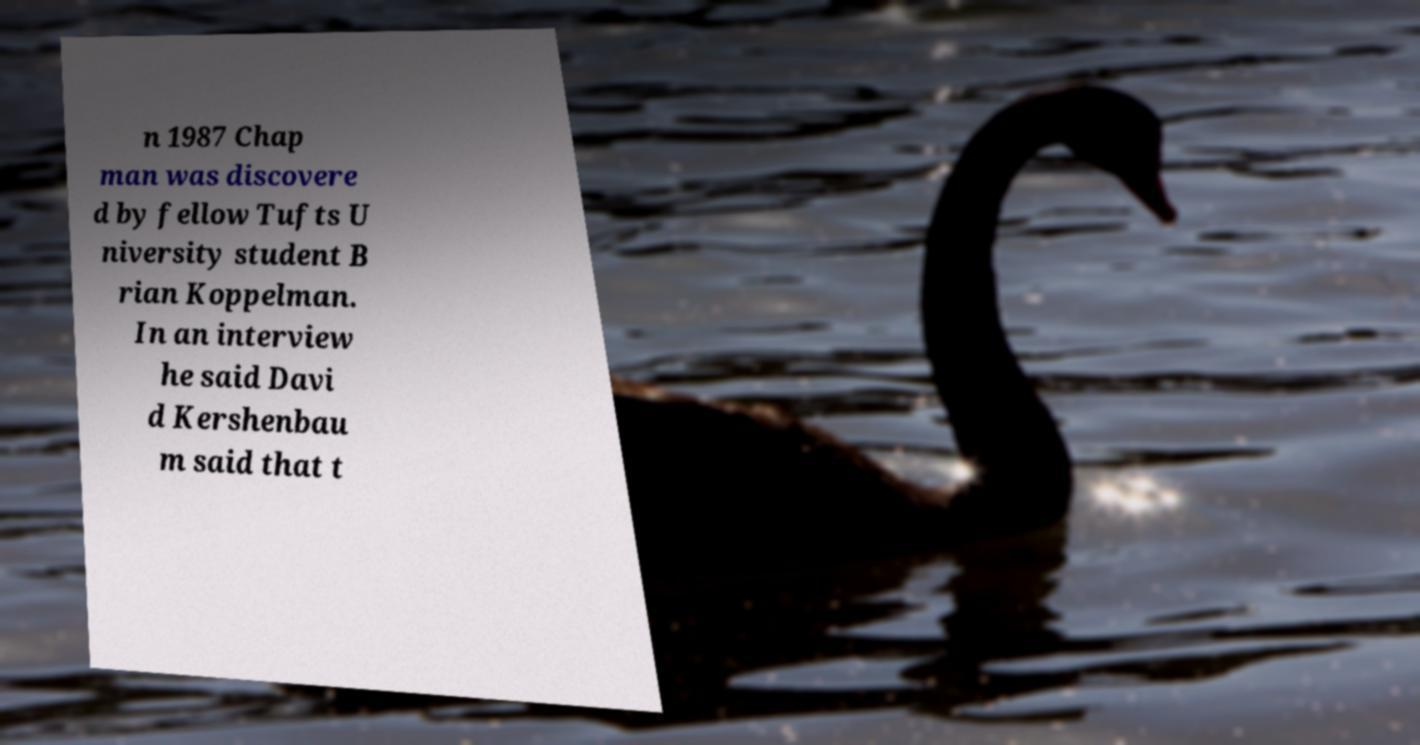There's text embedded in this image that I need extracted. Can you transcribe it verbatim? n 1987 Chap man was discovere d by fellow Tufts U niversity student B rian Koppelman. In an interview he said Davi d Kershenbau m said that t 